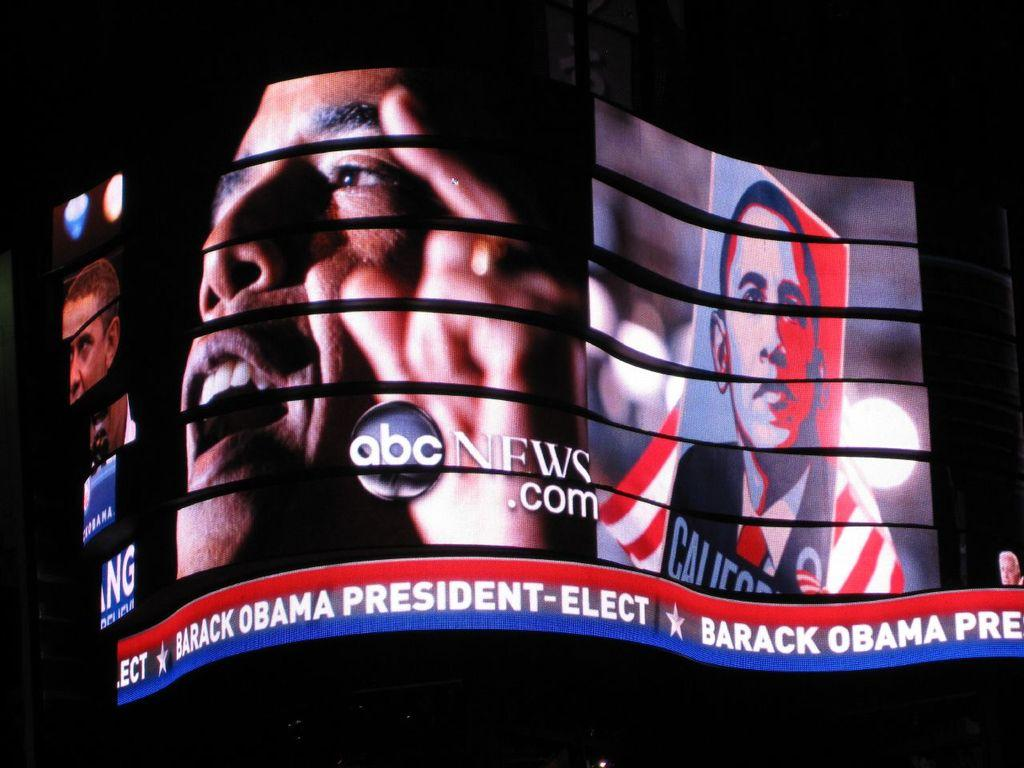What is the main object in the image? There is a screen in the image. What is displayed on the screen? There is a picture of a man on the screen. Are there any words or phrases on the screen? Yes, there is text visible on the screen. Where is the zoo located in the image? There is no zoo present in the image; it only features a screen with a picture of a man and some text. 